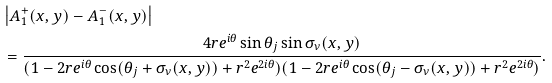<formula> <loc_0><loc_0><loc_500><loc_500>& \left | A _ { 1 } ^ { + } ( x , y ) - A _ { 1 } ^ { - } ( x , y ) \right | \\ & = \frac { 4 r e ^ { i \theta } \sin \theta _ { j } \sin \sigma _ { \nu } ( x , y ) } { ( 1 - 2 r e ^ { i \theta } \cos ( \theta _ { j } + \sigma _ { \nu } ( x , y ) ) + r ^ { 2 } e ^ { 2 i \theta } ) ( 1 - 2 r e ^ { i \theta } \cos ( \theta _ { j } - \sigma _ { \nu } ( x , y ) ) + r ^ { 2 } e ^ { 2 i \theta } ) } .</formula> 